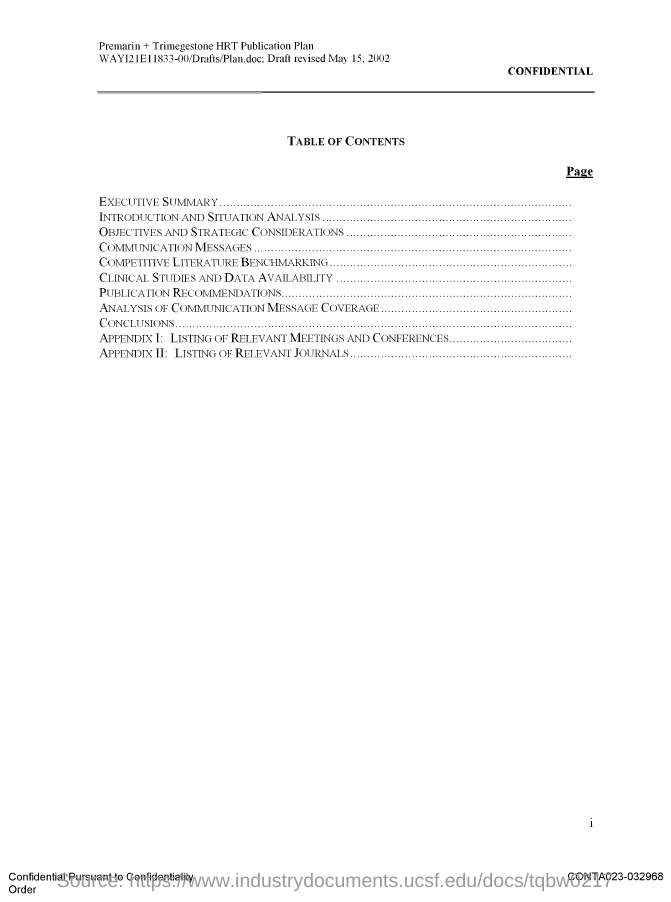What is the Page Number?
Provide a short and direct response. I. 